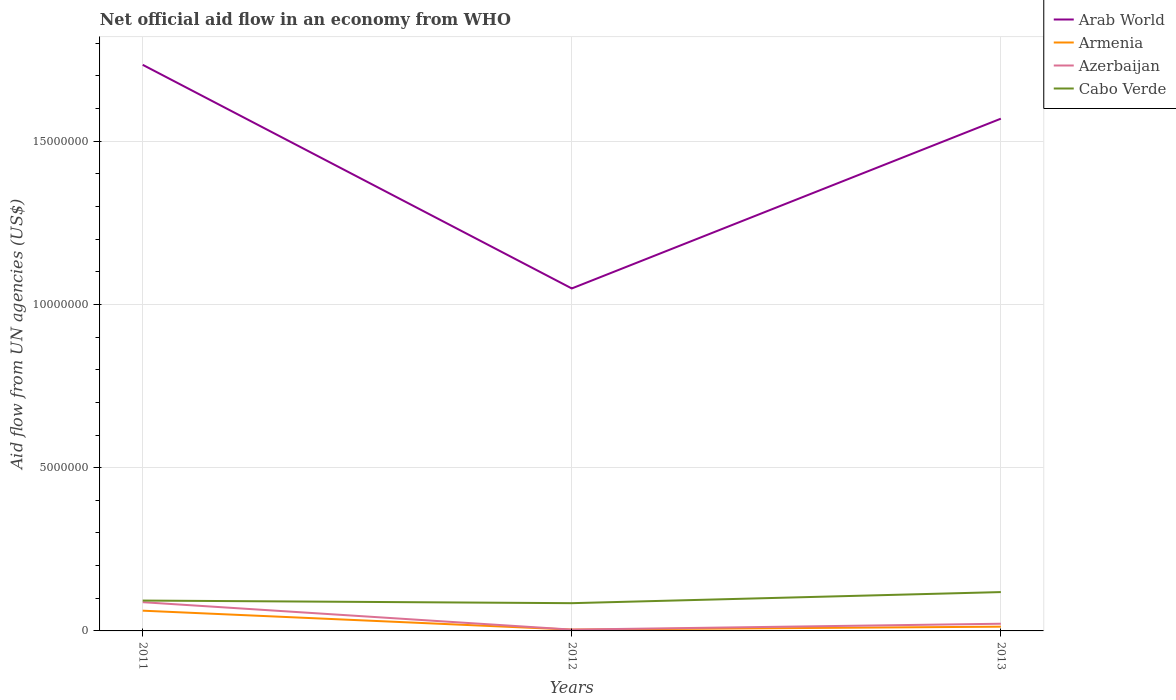How many different coloured lines are there?
Offer a terse response. 4. Is the number of lines equal to the number of legend labels?
Offer a very short reply. Yes. Across all years, what is the maximum net official aid flow in Arab World?
Offer a very short reply. 1.05e+07. What is the total net official aid flow in Cabo Verde in the graph?
Your answer should be compact. -2.60e+05. What is the difference between the highest and the second highest net official aid flow in Armenia?
Keep it short and to the point. 5.80e+05. How many lines are there?
Make the answer very short. 4. How many years are there in the graph?
Keep it short and to the point. 3. What is the difference between two consecutive major ticks on the Y-axis?
Offer a terse response. 5.00e+06. Are the values on the major ticks of Y-axis written in scientific E-notation?
Offer a very short reply. No. Does the graph contain any zero values?
Keep it short and to the point. No. Does the graph contain grids?
Offer a very short reply. Yes. Where does the legend appear in the graph?
Offer a terse response. Top right. How many legend labels are there?
Give a very brief answer. 4. How are the legend labels stacked?
Provide a succinct answer. Vertical. What is the title of the graph?
Your answer should be very brief. Net official aid flow in an economy from WHO. What is the label or title of the X-axis?
Ensure brevity in your answer.  Years. What is the label or title of the Y-axis?
Make the answer very short. Aid flow from UN agencies (US$). What is the Aid flow from UN agencies (US$) of Arab World in 2011?
Give a very brief answer. 1.73e+07. What is the Aid flow from UN agencies (US$) in Armenia in 2011?
Offer a very short reply. 6.20e+05. What is the Aid flow from UN agencies (US$) in Azerbaijan in 2011?
Provide a short and direct response. 8.80e+05. What is the Aid flow from UN agencies (US$) of Cabo Verde in 2011?
Offer a very short reply. 9.30e+05. What is the Aid flow from UN agencies (US$) of Arab World in 2012?
Your answer should be compact. 1.05e+07. What is the Aid flow from UN agencies (US$) in Cabo Verde in 2012?
Provide a short and direct response. 8.50e+05. What is the Aid flow from UN agencies (US$) in Arab World in 2013?
Give a very brief answer. 1.57e+07. What is the Aid flow from UN agencies (US$) in Armenia in 2013?
Offer a terse response. 1.30e+05. What is the Aid flow from UN agencies (US$) of Cabo Verde in 2013?
Your answer should be very brief. 1.19e+06. Across all years, what is the maximum Aid flow from UN agencies (US$) in Arab World?
Offer a very short reply. 1.73e+07. Across all years, what is the maximum Aid flow from UN agencies (US$) in Armenia?
Your answer should be very brief. 6.20e+05. Across all years, what is the maximum Aid flow from UN agencies (US$) in Azerbaijan?
Offer a terse response. 8.80e+05. Across all years, what is the maximum Aid flow from UN agencies (US$) of Cabo Verde?
Keep it short and to the point. 1.19e+06. Across all years, what is the minimum Aid flow from UN agencies (US$) in Arab World?
Give a very brief answer. 1.05e+07. Across all years, what is the minimum Aid flow from UN agencies (US$) of Azerbaijan?
Provide a succinct answer. 4.00e+04. Across all years, what is the minimum Aid flow from UN agencies (US$) in Cabo Verde?
Offer a very short reply. 8.50e+05. What is the total Aid flow from UN agencies (US$) of Arab World in the graph?
Your answer should be very brief. 4.35e+07. What is the total Aid flow from UN agencies (US$) of Armenia in the graph?
Make the answer very short. 7.90e+05. What is the total Aid flow from UN agencies (US$) in Azerbaijan in the graph?
Ensure brevity in your answer.  1.14e+06. What is the total Aid flow from UN agencies (US$) of Cabo Verde in the graph?
Your answer should be very brief. 2.97e+06. What is the difference between the Aid flow from UN agencies (US$) in Arab World in 2011 and that in 2012?
Offer a terse response. 6.85e+06. What is the difference between the Aid flow from UN agencies (US$) in Armenia in 2011 and that in 2012?
Offer a very short reply. 5.80e+05. What is the difference between the Aid flow from UN agencies (US$) in Azerbaijan in 2011 and that in 2012?
Give a very brief answer. 8.40e+05. What is the difference between the Aid flow from UN agencies (US$) in Cabo Verde in 2011 and that in 2012?
Your response must be concise. 8.00e+04. What is the difference between the Aid flow from UN agencies (US$) in Arab World in 2011 and that in 2013?
Provide a short and direct response. 1.65e+06. What is the difference between the Aid flow from UN agencies (US$) in Armenia in 2011 and that in 2013?
Provide a short and direct response. 4.90e+05. What is the difference between the Aid flow from UN agencies (US$) in Arab World in 2012 and that in 2013?
Provide a short and direct response. -5.20e+06. What is the difference between the Aid flow from UN agencies (US$) in Cabo Verde in 2012 and that in 2013?
Your answer should be compact. -3.40e+05. What is the difference between the Aid flow from UN agencies (US$) of Arab World in 2011 and the Aid flow from UN agencies (US$) of Armenia in 2012?
Keep it short and to the point. 1.73e+07. What is the difference between the Aid flow from UN agencies (US$) of Arab World in 2011 and the Aid flow from UN agencies (US$) of Azerbaijan in 2012?
Offer a very short reply. 1.73e+07. What is the difference between the Aid flow from UN agencies (US$) of Arab World in 2011 and the Aid flow from UN agencies (US$) of Cabo Verde in 2012?
Offer a very short reply. 1.65e+07. What is the difference between the Aid flow from UN agencies (US$) in Armenia in 2011 and the Aid flow from UN agencies (US$) in Azerbaijan in 2012?
Your response must be concise. 5.80e+05. What is the difference between the Aid flow from UN agencies (US$) in Armenia in 2011 and the Aid flow from UN agencies (US$) in Cabo Verde in 2012?
Your answer should be compact. -2.30e+05. What is the difference between the Aid flow from UN agencies (US$) of Azerbaijan in 2011 and the Aid flow from UN agencies (US$) of Cabo Verde in 2012?
Your answer should be compact. 3.00e+04. What is the difference between the Aid flow from UN agencies (US$) in Arab World in 2011 and the Aid flow from UN agencies (US$) in Armenia in 2013?
Provide a short and direct response. 1.72e+07. What is the difference between the Aid flow from UN agencies (US$) of Arab World in 2011 and the Aid flow from UN agencies (US$) of Azerbaijan in 2013?
Your answer should be compact. 1.71e+07. What is the difference between the Aid flow from UN agencies (US$) in Arab World in 2011 and the Aid flow from UN agencies (US$) in Cabo Verde in 2013?
Ensure brevity in your answer.  1.62e+07. What is the difference between the Aid flow from UN agencies (US$) of Armenia in 2011 and the Aid flow from UN agencies (US$) of Cabo Verde in 2013?
Offer a terse response. -5.70e+05. What is the difference between the Aid flow from UN agencies (US$) of Azerbaijan in 2011 and the Aid flow from UN agencies (US$) of Cabo Verde in 2013?
Offer a terse response. -3.10e+05. What is the difference between the Aid flow from UN agencies (US$) of Arab World in 2012 and the Aid flow from UN agencies (US$) of Armenia in 2013?
Provide a short and direct response. 1.04e+07. What is the difference between the Aid flow from UN agencies (US$) in Arab World in 2012 and the Aid flow from UN agencies (US$) in Azerbaijan in 2013?
Give a very brief answer. 1.03e+07. What is the difference between the Aid flow from UN agencies (US$) of Arab World in 2012 and the Aid flow from UN agencies (US$) of Cabo Verde in 2013?
Provide a short and direct response. 9.30e+06. What is the difference between the Aid flow from UN agencies (US$) of Armenia in 2012 and the Aid flow from UN agencies (US$) of Cabo Verde in 2013?
Your answer should be very brief. -1.15e+06. What is the difference between the Aid flow from UN agencies (US$) in Azerbaijan in 2012 and the Aid flow from UN agencies (US$) in Cabo Verde in 2013?
Offer a very short reply. -1.15e+06. What is the average Aid flow from UN agencies (US$) of Arab World per year?
Keep it short and to the point. 1.45e+07. What is the average Aid flow from UN agencies (US$) of Armenia per year?
Offer a terse response. 2.63e+05. What is the average Aid flow from UN agencies (US$) of Azerbaijan per year?
Offer a very short reply. 3.80e+05. What is the average Aid flow from UN agencies (US$) of Cabo Verde per year?
Give a very brief answer. 9.90e+05. In the year 2011, what is the difference between the Aid flow from UN agencies (US$) of Arab World and Aid flow from UN agencies (US$) of Armenia?
Offer a terse response. 1.67e+07. In the year 2011, what is the difference between the Aid flow from UN agencies (US$) in Arab World and Aid flow from UN agencies (US$) in Azerbaijan?
Ensure brevity in your answer.  1.65e+07. In the year 2011, what is the difference between the Aid flow from UN agencies (US$) in Arab World and Aid flow from UN agencies (US$) in Cabo Verde?
Ensure brevity in your answer.  1.64e+07. In the year 2011, what is the difference between the Aid flow from UN agencies (US$) in Armenia and Aid flow from UN agencies (US$) in Cabo Verde?
Offer a terse response. -3.10e+05. In the year 2012, what is the difference between the Aid flow from UN agencies (US$) of Arab World and Aid flow from UN agencies (US$) of Armenia?
Provide a short and direct response. 1.04e+07. In the year 2012, what is the difference between the Aid flow from UN agencies (US$) of Arab World and Aid flow from UN agencies (US$) of Azerbaijan?
Your answer should be very brief. 1.04e+07. In the year 2012, what is the difference between the Aid flow from UN agencies (US$) in Arab World and Aid flow from UN agencies (US$) in Cabo Verde?
Offer a very short reply. 9.64e+06. In the year 2012, what is the difference between the Aid flow from UN agencies (US$) of Armenia and Aid flow from UN agencies (US$) of Cabo Verde?
Your response must be concise. -8.10e+05. In the year 2012, what is the difference between the Aid flow from UN agencies (US$) of Azerbaijan and Aid flow from UN agencies (US$) of Cabo Verde?
Provide a succinct answer. -8.10e+05. In the year 2013, what is the difference between the Aid flow from UN agencies (US$) in Arab World and Aid flow from UN agencies (US$) in Armenia?
Provide a succinct answer. 1.56e+07. In the year 2013, what is the difference between the Aid flow from UN agencies (US$) of Arab World and Aid flow from UN agencies (US$) of Azerbaijan?
Offer a terse response. 1.55e+07. In the year 2013, what is the difference between the Aid flow from UN agencies (US$) in Arab World and Aid flow from UN agencies (US$) in Cabo Verde?
Give a very brief answer. 1.45e+07. In the year 2013, what is the difference between the Aid flow from UN agencies (US$) of Armenia and Aid flow from UN agencies (US$) of Azerbaijan?
Give a very brief answer. -9.00e+04. In the year 2013, what is the difference between the Aid flow from UN agencies (US$) of Armenia and Aid flow from UN agencies (US$) of Cabo Verde?
Offer a terse response. -1.06e+06. In the year 2013, what is the difference between the Aid flow from UN agencies (US$) in Azerbaijan and Aid flow from UN agencies (US$) in Cabo Verde?
Ensure brevity in your answer.  -9.70e+05. What is the ratio of the Aid flow from UN agencies (US$) of Arab World in 2011 to that in 2012?
Ensure brevity in your answer.  1.65. What is the ratio of the Aid flow from UN agencies (US$) in Azerbaijan in 2011 to that in 2012?
Keep it short and to the point. 22. What is the ratio of the Aid flow from UN agencies (US$) of Cabo Verde in 2011 to that in 2012?
Your response must be concise. 1.09. What is the ratio of the Aid flow from UN agencies (US$) of Arab World in 2011 to that in 2013?
Offer a terse response. 1.11. What is the ratio of the Aid flow from UN agencies (US$) in Armenia in 2011 to that in 2013?
Offer a terse response. 4.77. What is the ratio of the Aid flow from UN agencies (US$) of Cabo Verde in 2011 to that in 2013?
Offer a very short reply. 0.78. What is the ratio of the Aid flow from UN agencies (US$) of Arab World in 2012 to that in 2013?
Give a very brief answer. 0.67. What is the ratio of the Aid flow from UN agencies (US$) of Armenia in 2012 to that in 2013?
Provide a short and direct response. 0.31. What is the ratio of the Aid flow from UN agencies (US$) of Azerbaijan in 2012 to that in 2013?
Offer a terse response. 0.18. What is the ratio of the Aid flow from UN agencies (US$) in Cabo Verde in 2012 to that in 2013?
Your answer should be compact. 0.71. What is the difference between the highest and the second highest Aid flow from UN agencies (US$) of Arab World?
Your answer should be compact. 1.65e+06. What is the difference between the highest and the second highest Aid flow from UN agencies (US$) in Armenia?
Offer a very short reply. 4.90e+05. What is the difference between the highest and the second highest Aid flow from UN agencies (US$) in Cabo Verde?
Your response must be concise. 2.60e+05. What is the difference between the highest and the lowest Aid flow from UN agencies (US$) of Arab World?
Offer a terse response. 6.85e+06. What is the difference between the highest and the lowest Aid flow from UN agencies (US$) in Armenia?
Offer a very short reply. 5.80e+05. What is the difference between the highest and the lowest Aid flow from UN agencies (US$) of Azerbaijan?
Offer a terse response. 8.40e+05. What is the difference between the highest and the lowest Aid flow from UN agencies (US$) in Cabo Verde?
Keep it short and to the point. 3.40e+05. 